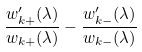Convert formula to latex. <formula><loc_0><loc_0><loc_500><loc_500>\frac { w _ { k + } ^ { \prime } ( \lambda ) } { w _ { k + } ( \lambda ) } - \frac { w _ { k - } ^ { \prime } ( \lambda ) } { w _ { k - } ( \lambda ) }</formula> 